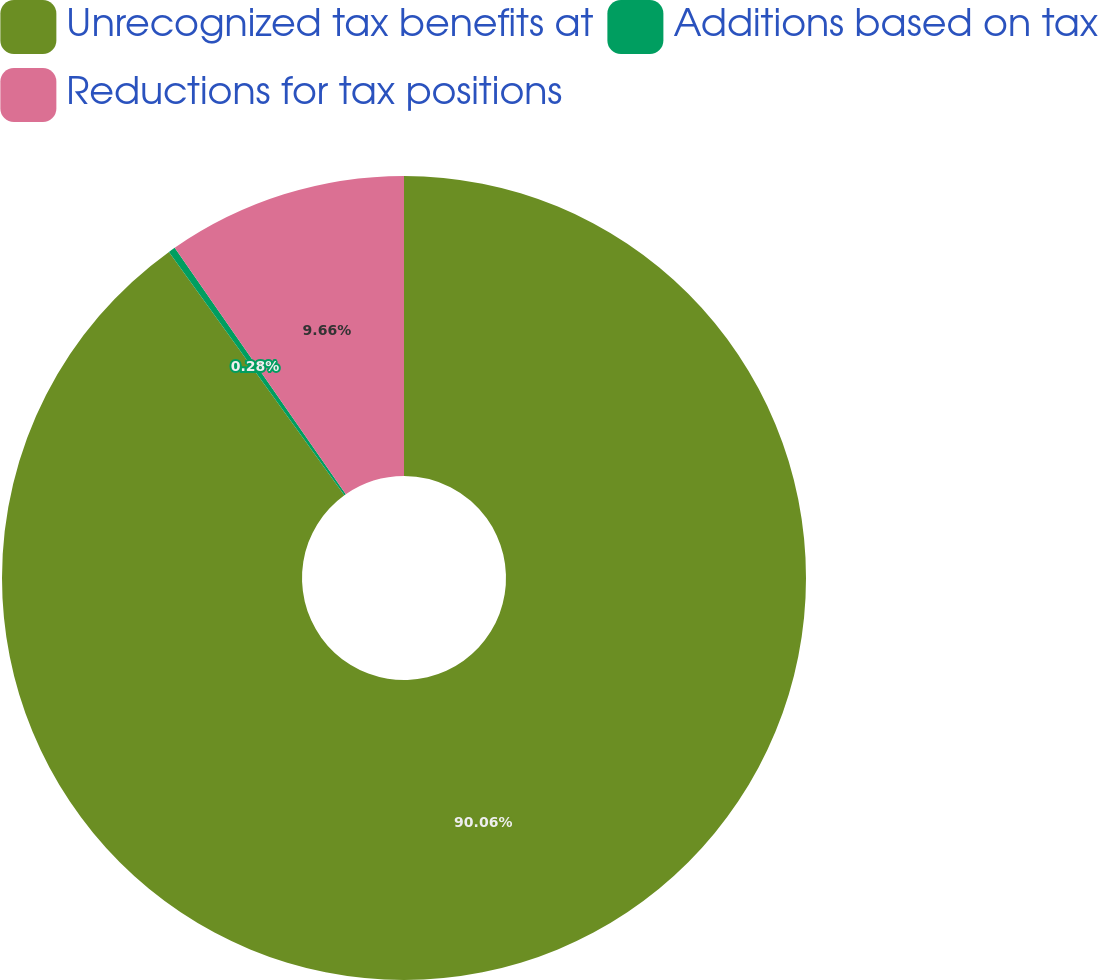Convert chart to OTSL. <chart><loc_0><loc_0><loc_500><loc_500><pie_chart><fcel>Unrecognized tax benefits at<fcel>Additions based on tax<fcel>Reductions for tax positions<nl><fcel>90.06%<fcel>0.28%<fcel>9.66%<nl></chart> 